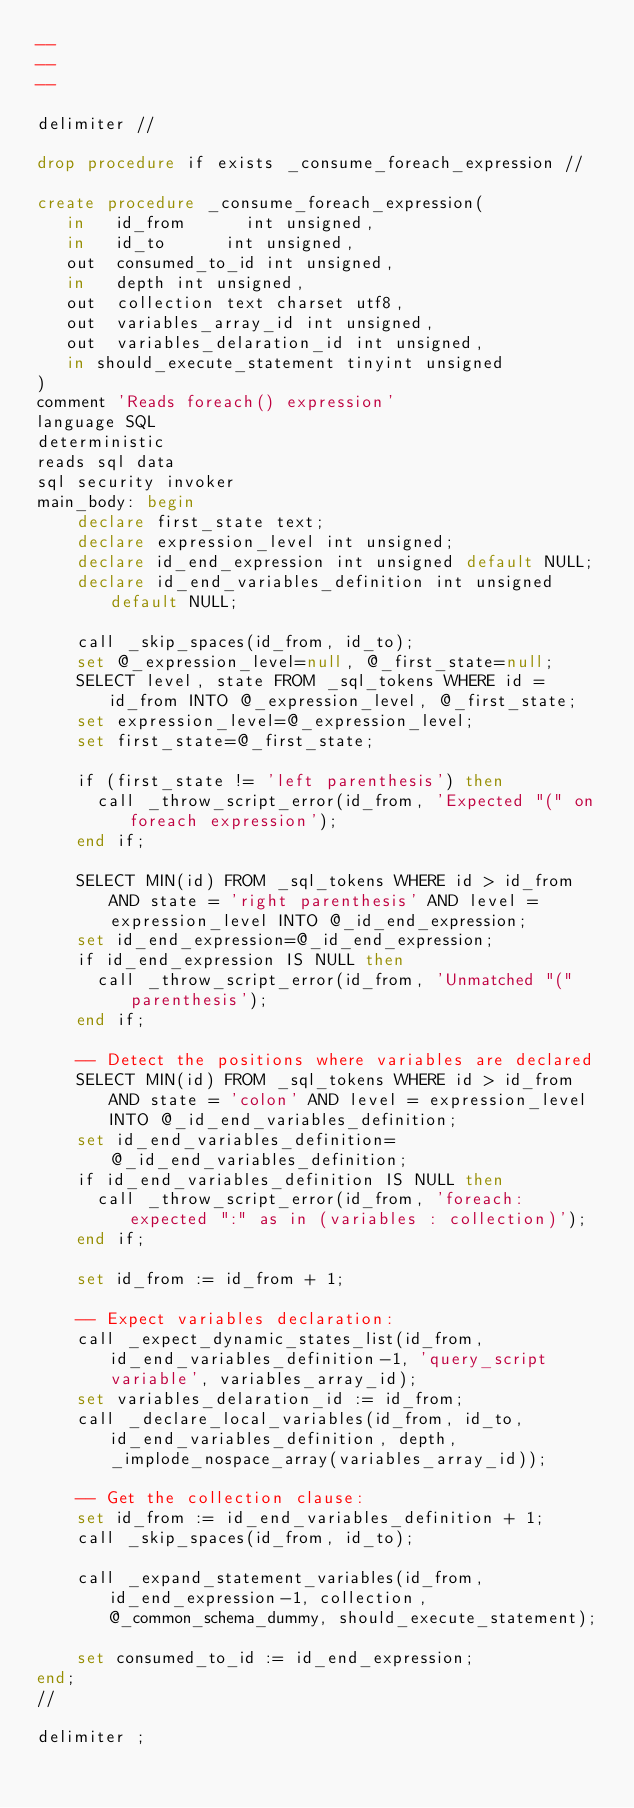<code> <loc_0><loc_0><loc_500><loc_500><_SQL_>--
--
--

delimiter //

drop procedure if exists _consume_foreach_expression //

create procedure _consume_foreach_expression(
   in   id_from      int unsigned,
   in   id_to      int unsigned,
   out  consumed_to_id int unsigned,
   in   depth int unsigned,
   out  collection text charset utf8,
   out  variables_array_id int unsigned,
   out  variables_delaration_id int unsigned,
   in should_execute_statement tinyint unsigned
)
comment 'Reads foreach() expression'
language SQL
deterministic
reads sql data
sql security invoker
main_body: begin
    declare first_state text;
    declare expression_level int unsigned;
    declare id_end_expression int unsigned default NULL;
    declare id_end_variables_definition int unsigned default NULL;

    call _skip_spaces(id_from, id_to);
    set @_expression_level=null, @_first_state=null;
    SELECT level, state FROM _sql_tokens WHERE id = id_from INTO @_expression_level, @_first_state;
    set expression_level=@_expression_level;
    set first_state=@_first_state;

    if (first_state != 'left parenthesis') then
      call _throw_script_error(id_from, 'Expected "(" on foreach expression');
    end if;

    SELECT MIN(id) FROM _sql_tokens WHERE id > id_from AND state = 'right parenthesis' AND level = expression_level INTO @_id_end_expression;
    set id_end_expression=@_id_end_expression;
  	if id_end_expression IS NULL then
	  call _throw_script_error(id_from, 'Unmatched "(" parenthesis');
	end if;

	-- Detect the positions where variables are declared
    SELECT MIN(id) FROM _sql_tokens WHERE id > id_from AND state = 'colon' AND level = expression_level INTO @_id_end_variables_definition;
    set id_end_variables_definition=@_id_end_variables_definition;
  	if id_end_variables_definition IS NULL then
	  call _throw_script_error(id_from, 'foreach: expected ":" as in (variables : collection)');
	end if;

    set id_from := id_from + 1;

	-- Expect variables declaration:
    call _expect_dynamic_states_list(id_from, id_end_variables_definition-1, 'query_script variable', variables_array_id);
	set variables_delaration_id := id_from;
	call _declare_local_variables(id_from, id_to, id_end_variables_definition, depth, _implode_nospace_array(variables_array_id));

    -- Get the collection clause:
	set id_from := id_end_variables_definition + 1;
    call _skip_spaces(id_from, id_to);

    call _expand_statement_variables(id_from, id_end_expression-1, collection, @_common_schema_dummy, should_execute_statement);

    set consumed_to_id := id_end_expression;
end;
//

delimiter ;
</code> 